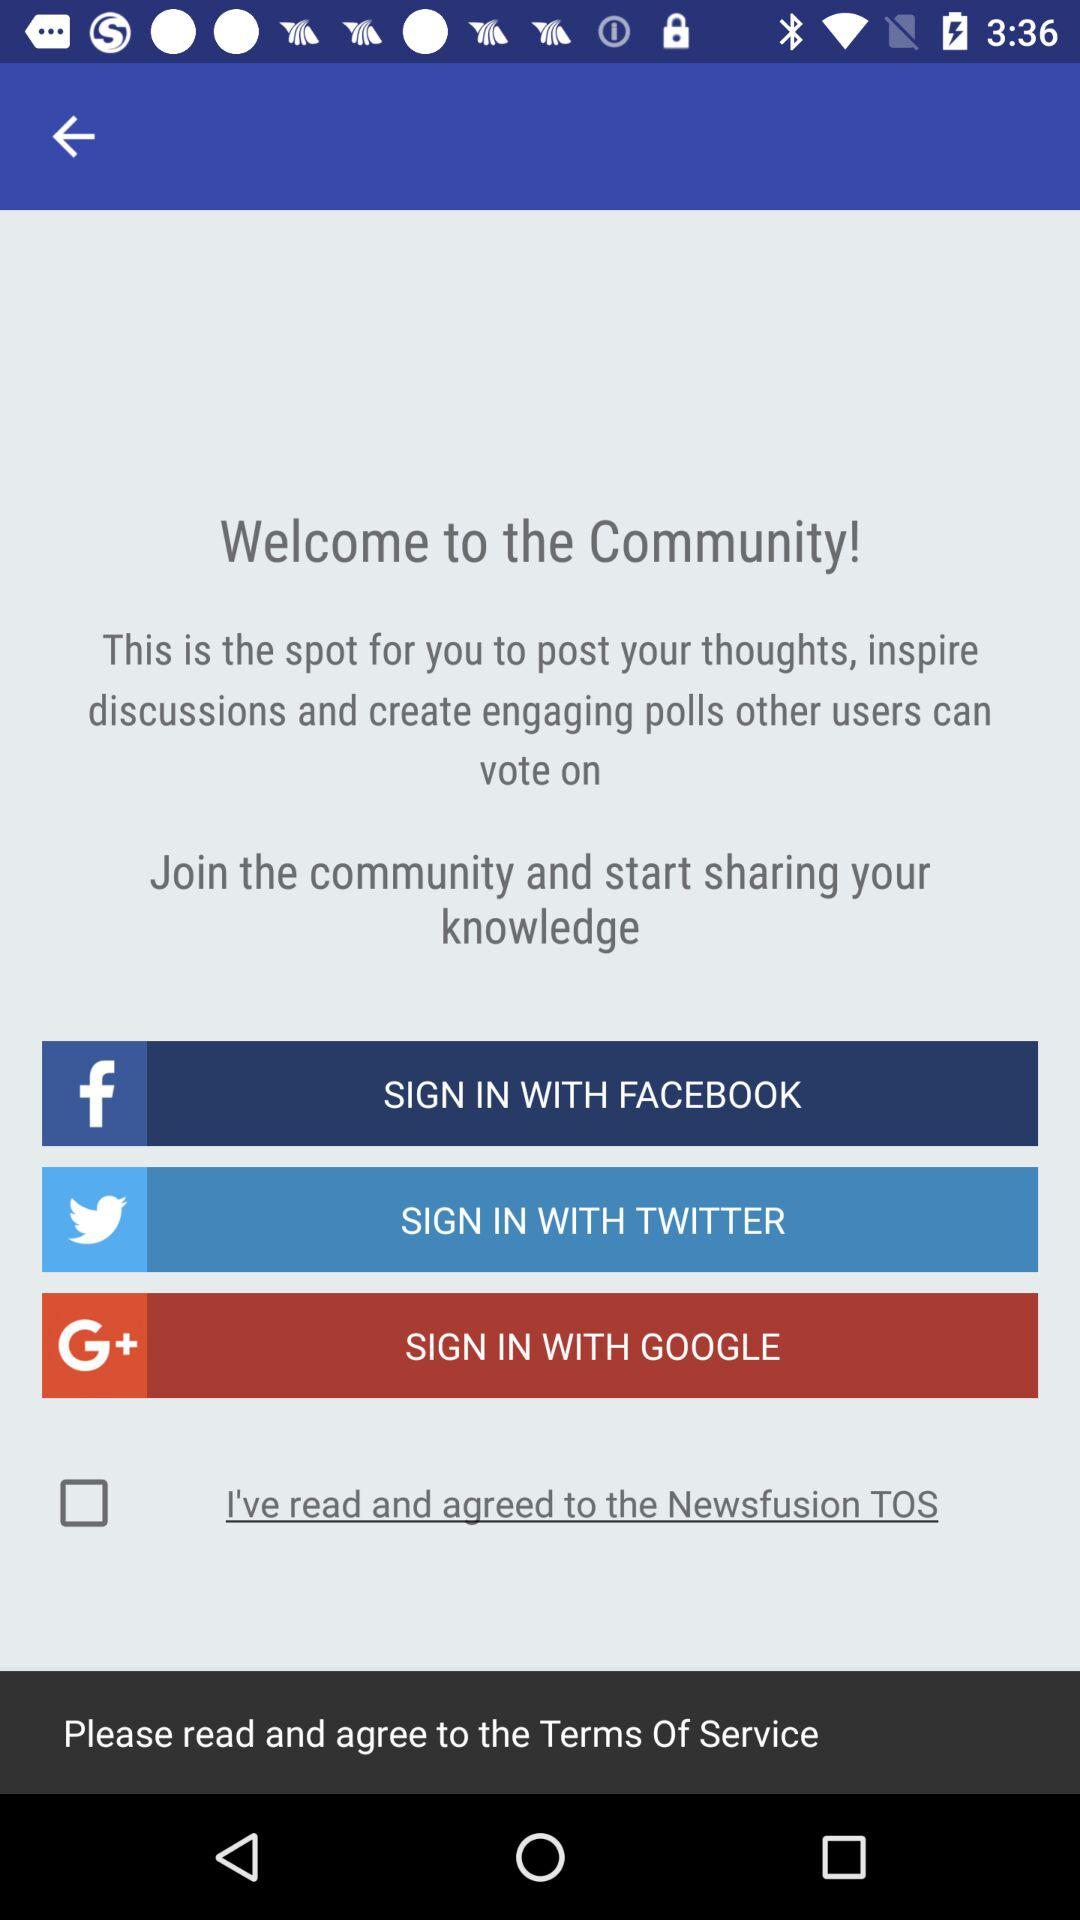What is the application name? The application name is "Newsfusion". 